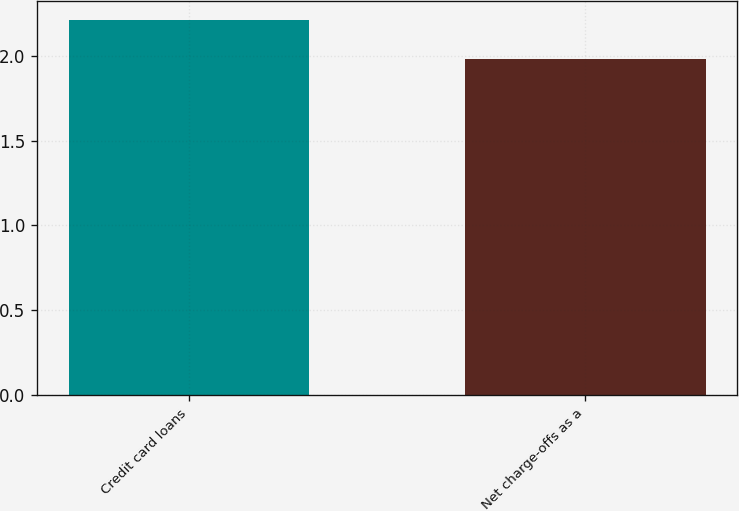Convert chart to OTSL. <chart><loc_0><loc_0><loc_500><loc_500><bar_chart><fcel>Credit card loans<fcel>Net charge-offs as a<nl><fcel>2.21<fcel>1.98<nl></chart> 